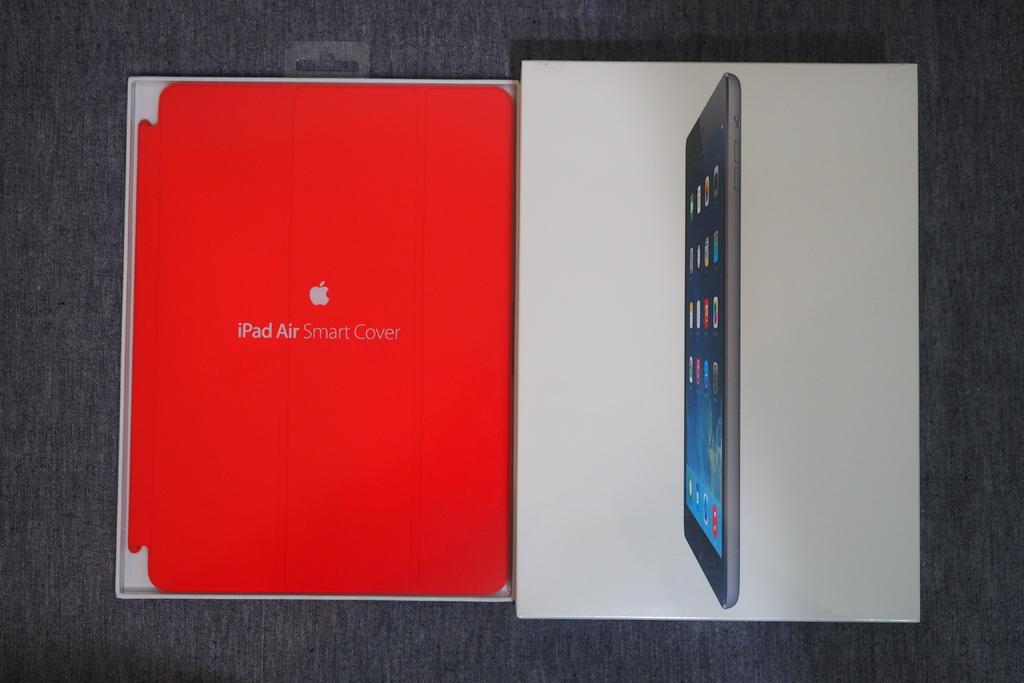<image>
Give a short and clear explanation of the subsequent image. The box of an iPad Air is opened on a gray surface. 